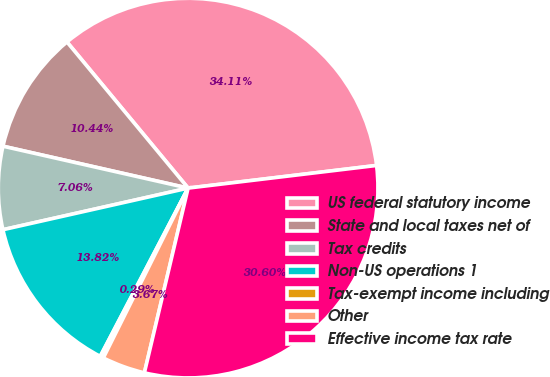Convert chart to OTSL. <chart><loc_0><loc_0><loc_500><loc_500><pie_chart><fcel>US federal statutory income<fcel>State and local taxes net of<fcel>Tax credits<fcel>Non-US operations 1<fcel>Tax-exempt income including<fcel>Other<fcel>Effective income tax rate<nl><fcel>34.11%<fcel>10.44%<fcel>7.06%<fcel>13.82%<fcel>0.29%<fcel>3.67%<fcel>30.6%<nl></chart> 